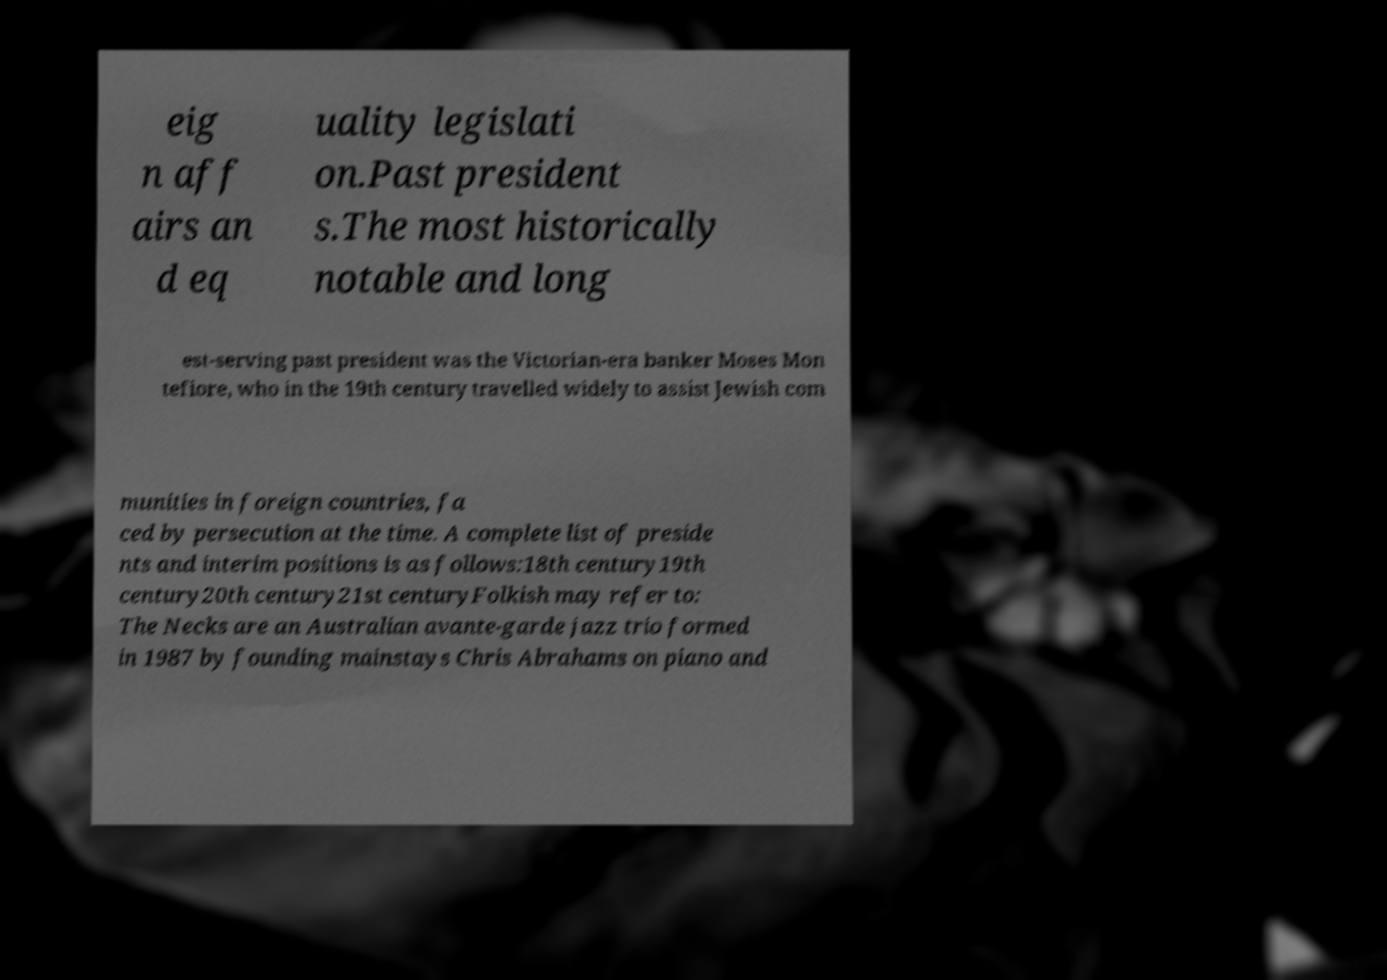Could you extract and type out the text from this image? eig n aff airs an d eq uality legislati on.Past president s.The most historically notable and long est-serving past president was the Victorian-era banker Moses Mon tefiore, who in the 19th century travelled widely to assist Jewish com munities in foreign countries, fa ced by persecution at the time. A complete list of preside nts and interim positions is as follows:18th century19th century20th century21st centuryFolkish may refer to: The Necks are an Australian avante-garde jazz trio formed in 1987 by founding mainstays Chris Abrahams on piano and 